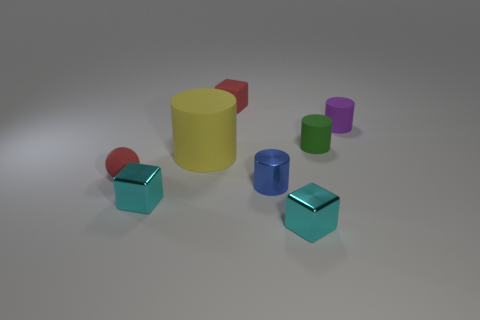Are there any other things that are the same size as the yellow matte thing?
Give a very brief answer. No. How many other objects are there of the same color as the small sphere?
Your answer should be very brief. 1. There is a metallic block on the left side of the tiny matte block; is it the same size as the red object behind the tiny green cylinder?
Offer a very short reply. Yes. There is a cyan cube that is to the right of the small cylinder that is in front of the big cylinder; what size is it?
Your answer should be very brief. Small. What is the small cylinder that is both behind the tiny sphere and on the left side of the tiny purple rubber thing made of?
Give a very brief answer. Rubber. The tiny sphere is what color?
Your response must be concise. Red. Is there any other thing that has the same material as the tiny blue object?
Give a very brief answer. Yes. There is a rubber thing that is in front of the big matte cylinder; what is its shape?
Provide a succinct answer. Sphere. There is a block that is on the right side of the small block that is behind the tiny purple object; is there a small red object on the right side of it?
Your answer should be compact. No. Is there anything else that has the same shape as the purple object?
Your answer should be very brief. Yes. 